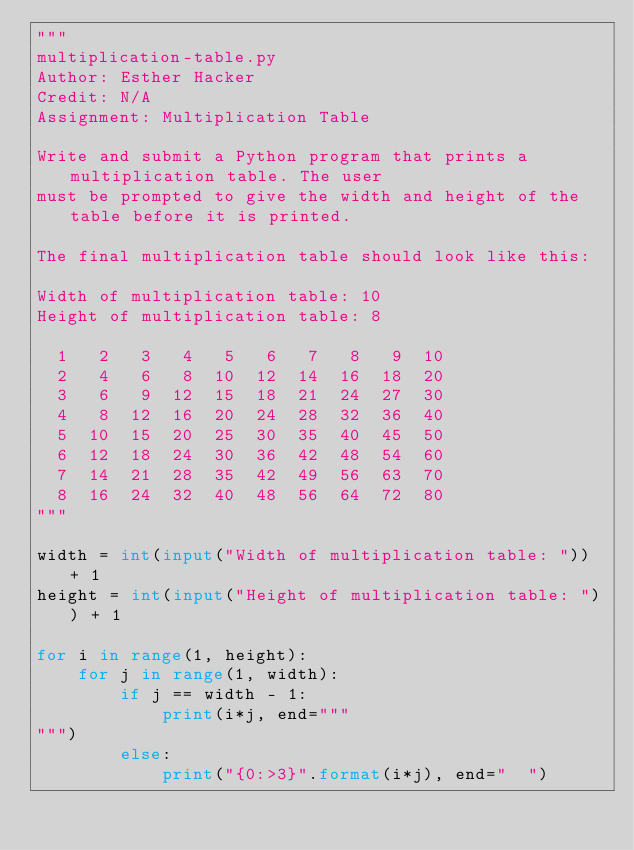Convert code to text. <code><loc_0><loc_0><loc_500><loc_500><_Python_>"""
multiplication-table.py
Author: Esther Hacker
Credit: N/A
Assignment: Multiplication Table

Write and submit a Python program that prints a multiplication table. The user 
must be prompted to give the width and height of the table before it is printed.

The final multiplication table should look like this:

Width of multiplication table: 10
Height of multiplication table: 8

  1   2   3   4   5   6   7   8   9  10
  2   4   6   8  10  12  14  16  18  20
  3   6   9  12  15  18  21  24  27  30
  4   8  12  16  20  24  28  32  36  40
  5  10  15  20  25  30  35  40  45  50
  6  12  18  24  30  36  42  48  54  60
  7  14  21  28  35  42  49  56  63  70
  8  16  24  32  40  48  56  64  72  80
"""

width = int(input("Width of multiplication table: ")) + 1
height = int(input("Height of multiplication table: ")) + 1

for i in range(1, height):
    for j in range(1, width):
        if j == width - 1:
            print(i*j, end="""
""")
        else:
            print("{0:>3}".format(i*j), end="  ")
</code> 